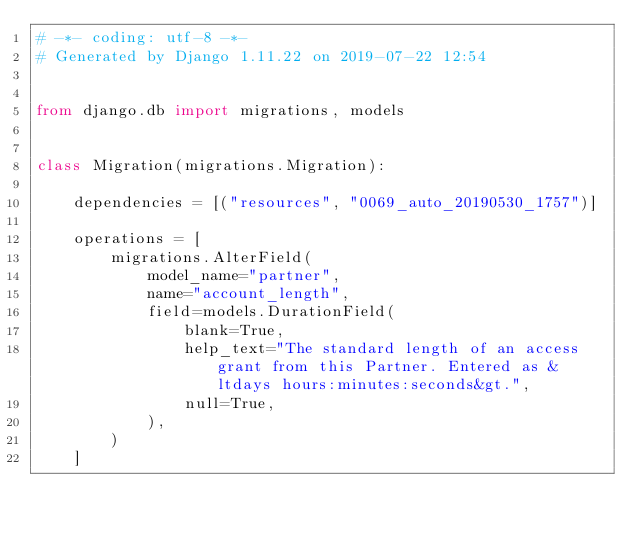Convert code to text. <code><loc_0><loc_0><loc_500><loc_500><_Python_># -*- coding: utf-8 -*-
# Generated by Django 1.11.22 on 2019-07-22 12:54


from django.db import migrations, models


class Migration(migrations.Migration):

    dependencies = [("resources", "0069_auto_20190530_1757")]

    operations = [
        migrations.AlterField(
            model_name="partner",
            name="account_length",
            field=models.DurationField(
                blank=True,
                help_text="The standard length of an access grant from this Partner. Entered as &ltdays hours:minutes:seconds&gt.",
                null=True,
            ),
        )
    ]
</code> 